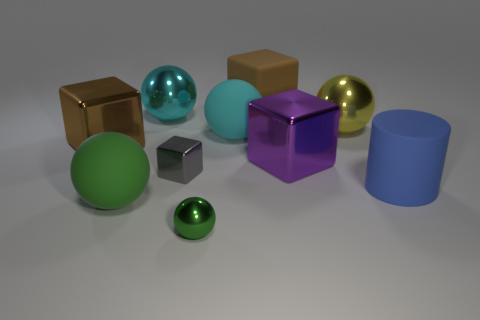There is a metallic thing that is the same color as the matte block; what is its shape?
Provide a succinct answer. Cube. There is a green ball that is the same material as the tiny block; what size is it?
Your answer should be very brief. Small. What shape is the cyan thing that is to the right of the small metal ball?
Offer a very short reply. Sphere. There is a metal ball in front of the big purple metallic object; does it have the same color as the big metallic cube on the left side of the brown rubber cube?
Offer a very short reply. No. There is a metallic cube that is the same color as the matte cube; what size is it?
Provide a short and direct response. Large. Is there a large red cube?
Your answer should be compact. No. What is the shape of the large thing behind the large ball behind the big metal ball to the right of the purple object?
Your answer should be very brief. Cube. There is a tiny cube; what number of green objects are right of it?
Provide a succinct answer. 1. Do the large thing that is in front of the blue rubber cylinder and the gray cube have the same material?
Give a very brief answer. No. How many other objects are there of the same shape as the brown shiny object?
Offer a terse response. 3. 